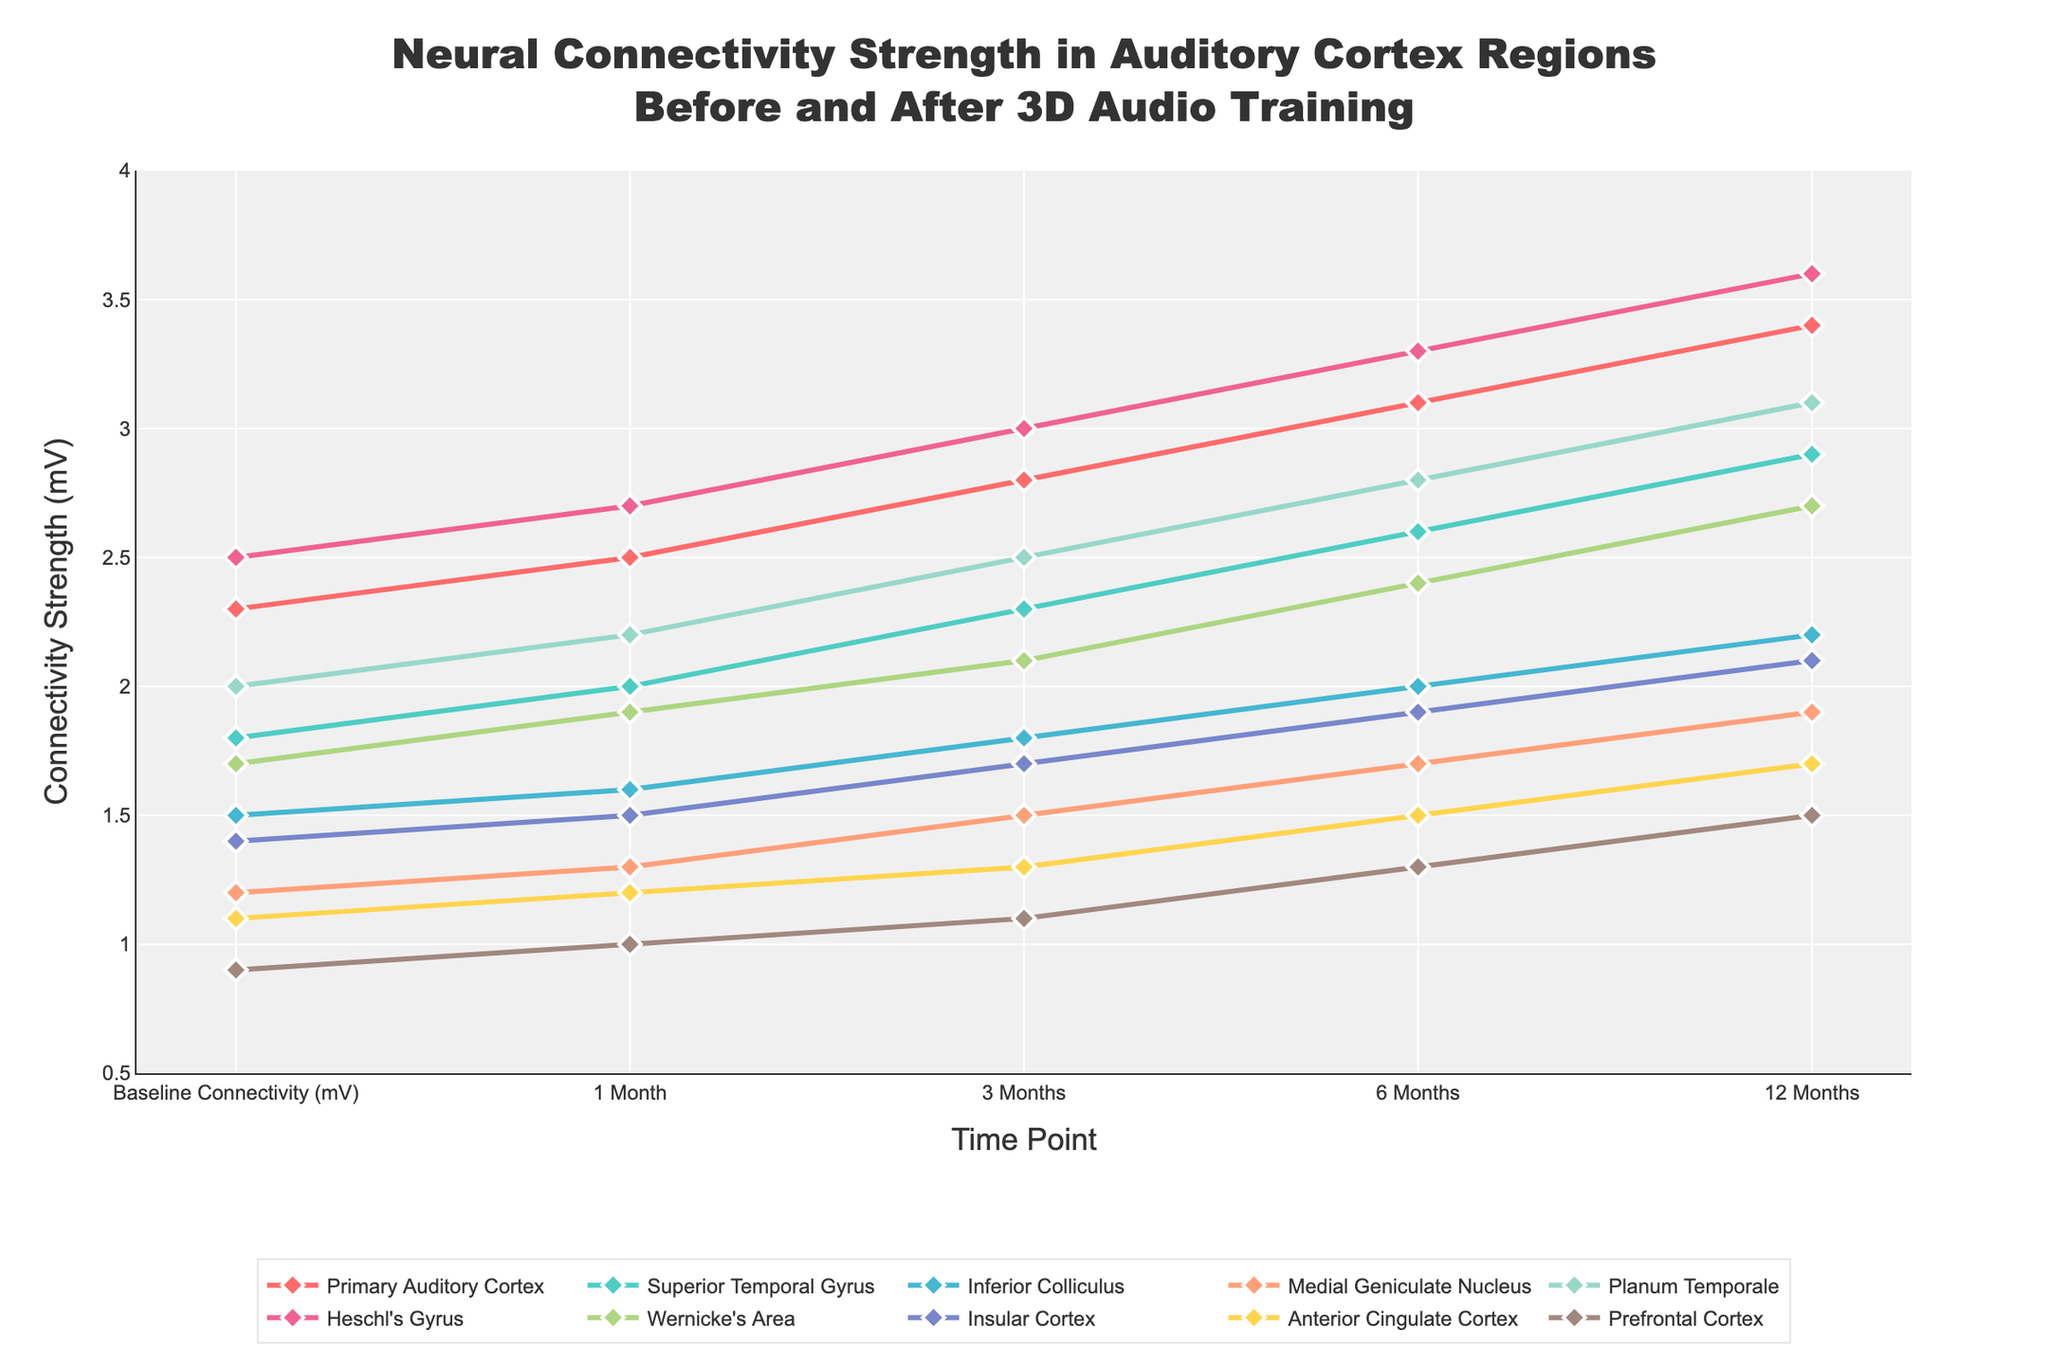What is the overall trend observed in the connectivity strength of the Primary Auditory Cortex over the 12-month period? The connectivity strength of the Primary Auditory Cortex shows a consistent increase throughout the 12-month period, from 2.3 mV at baseline to 3.4 mV at 12 months.
Answer: Increasing Which region exhibits the highest baseline connectivity strength, and what is its value? By examining the y-values at the baseline for each region, Heschl's Gyrus has the highest baseline connectivity strength at 2.5 mV.
Answer: Heschl's Gyrus, 2.5 mV How does the connectivity strength of the Insular Cortex change from baseline to 12 months? The Insular Cortex has a baseline connectivity strength of 1.4 mV, which increases to 2.1 mV at 12 months.
Answer: Increases from 1.4 mV to 2.1 mV Which two regions have the smallest difference in connectivity strength between baseline and 12 months? To find this, calculate the change for each region and then identify the smallest differences: Inferior Colliculus (0.7 mV) and Medial Geniculate Nucleus (0.7 mV) have the smallest differences.
Answer: Inferior Colliculus and Medial Geniculate Nucleus Does any region have a constant rate of increase in connectivity strength? If so, name the region(s). To determine a constant rate, check if the increases are uniform over each period. The Medial Geniculate Nucleus (increases of 0.2 mV every 3 months) shows a constant rate of increase.
Answer: Medial Geniculate Nucleus Which region has the greatest increase in connectivity strength from baseline to 1 month? By comparing the differences for each region, Heschl's Gyrus shows the greatest increase from 2.5 mV to 2.7 mV, which is a 0.2 mV increase.
Answer: Heschl's Gyrus What is the average connectivity strength of the Planum Temporale at all recorded time points? Sum the connectivity strengths at all time points (2.0 + 2.2 + 2.5 + 2.8 + 3.1) and divide by the number of time points (5). The total is 12.6 mV / 5 = 2.52 mV.
Answer: 2.52 mV Which two regions show the closest connectivity strength at the 6-month mark? Comparing the values at 6 months, Superior Temporal Gyrus (2.6 mV) and Planum Temporale (2.8 mV) are the closest in connectivity strength.
Answer: Superior Temporal Gyrus and Planum Temporale What is the connectivity strength of the Anterior Cingulate Cortex at 3 months, and how much has it increased from baseline? The Anterior Cingulate Cortex has a connectivity strength of 1.3 mV at 3 months, up from 1.1 mV at baseline. The increase is 1.3 - 1.1 = 0.2 mV.
Answer: 1.3 mV, increased by 0.2 mV Compare the connectivity strength of the Wernicke's Area at 12 months to the baseline connectivity strength of the Primary Auditory Cortex. Wernicke's Area has a connectivity strength of 2.7 mV at 12 months, which is higher than the baseline connectivity strength of the Primary Auditory Cortex at 2.3 mV.
Answer: Higher, 2.7 mV vs 2.3 mV 